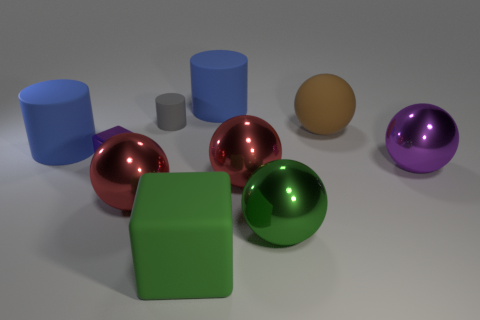Can you describe the colors and shapes of the objects on the left side of the image? On the left side of the image, there are cylindrical objects; one is large and blue, and the other is smaller and appears to be a shade of grey. Additionally, there's a cube that is green in color. What about the objects on the right side? The right side displays three spherical objects. Starting from the left, there's a shiny green ball, followed by a metallic red ball, and lastly, a purple ball with a metallic sheen. The far right includes a tan, non-metallic small sphere. 